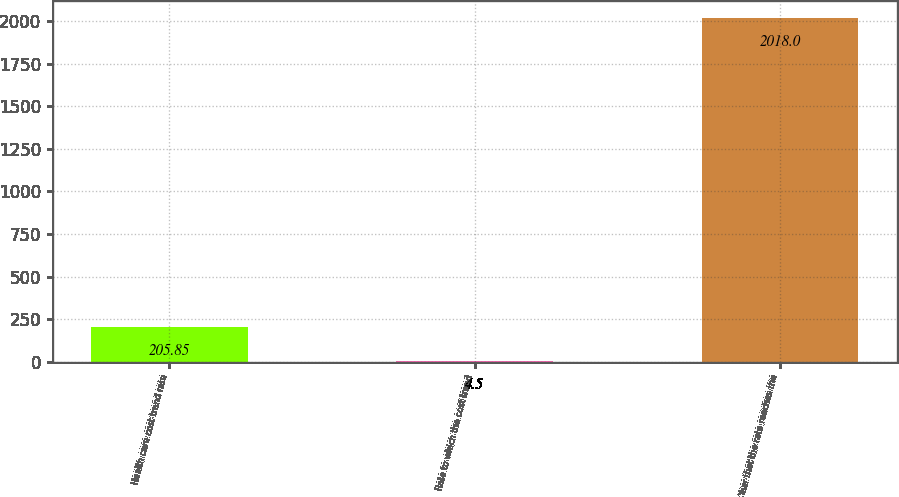Convert chart. <chart><loc_0><loc_0><loc_500><loc_500><bar_chart><fcel>Health care cost trend rate<fcel>Rate to which the cost trend<fcel>Year that the rate reaches the<nl><fcel>205.85<fcel>4.5<fcel>2018<nl></chart> 